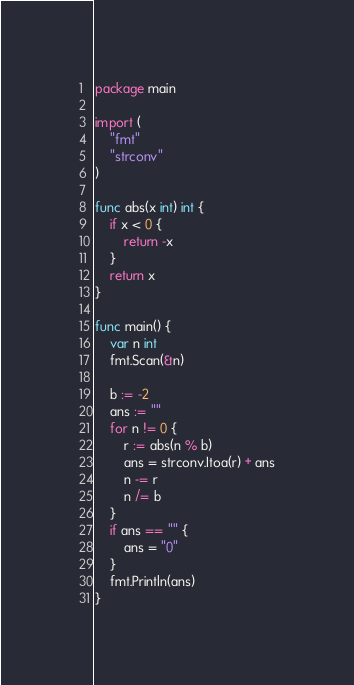<code> <loc_0><loc_0><loc_500><loc_500><_Go_>package main

import (
	"fmt"
	"strconv"
)

func abs(x int) int {
	if x < 0 {
		return -x
	}
	return x
}

func main() {
	var n int
	fmt.Scan(&n)

	b := -2
	ans := ""
	for n != 0 {
		r := abs(n % b)
		ans = strconv.Itoa(r) + ans
		n -= r
		n /= b
	}
	if ans == "" {
		ans = "0"
	}
	fmt.Println(ans)
}
</code> 